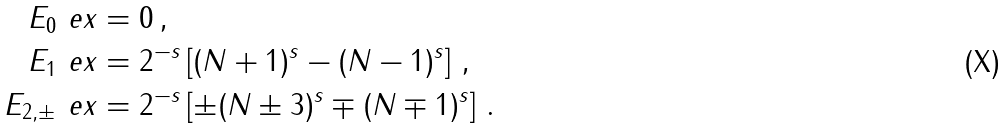Convert formula to latex. <formula><loc_0><loc_0><loc_500><loc_500>E _ { 0 } \ e x & = 0 \, , \\ \quad E _ { 1 } \ e x & = 2 ^ { - s } \left [ ( N + 1 ) ^ { s } - ( N - 1 ) ^ { s } \right ] \, , \\ E _ { 2 , \pm } \ e x & = 2 ^ { - s } \left [ \pm ( N \pm 3 ) ^ { s } \mp ( N \mp 1 ) ^ { s } \right ] \, .</formula> 